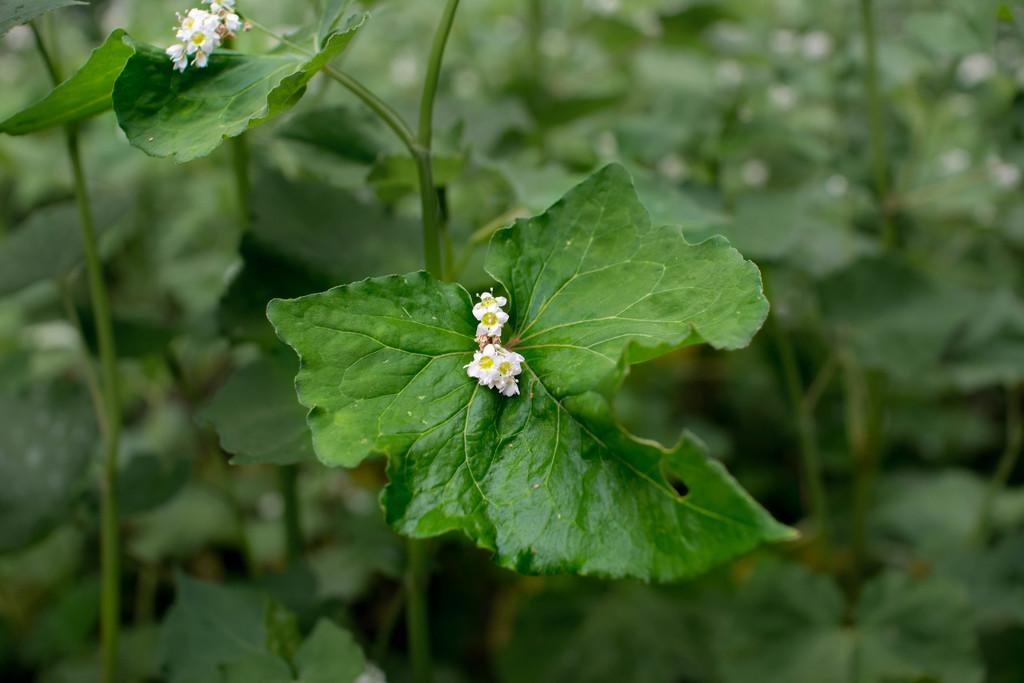What type of living organisms can be seen in the image? Plants and flowers are visible in the image. What color are the flowers in the image? The flowers in the image are white in color. What type of legal advice can be obtained from the flowers in the image? There are no lawyers or legal advice present in the image; it features plants and white flowers. How many hands are visible holding the flowers in the image? There are no hands or people holding the flowers in the image; it only shows plants and flowers. 